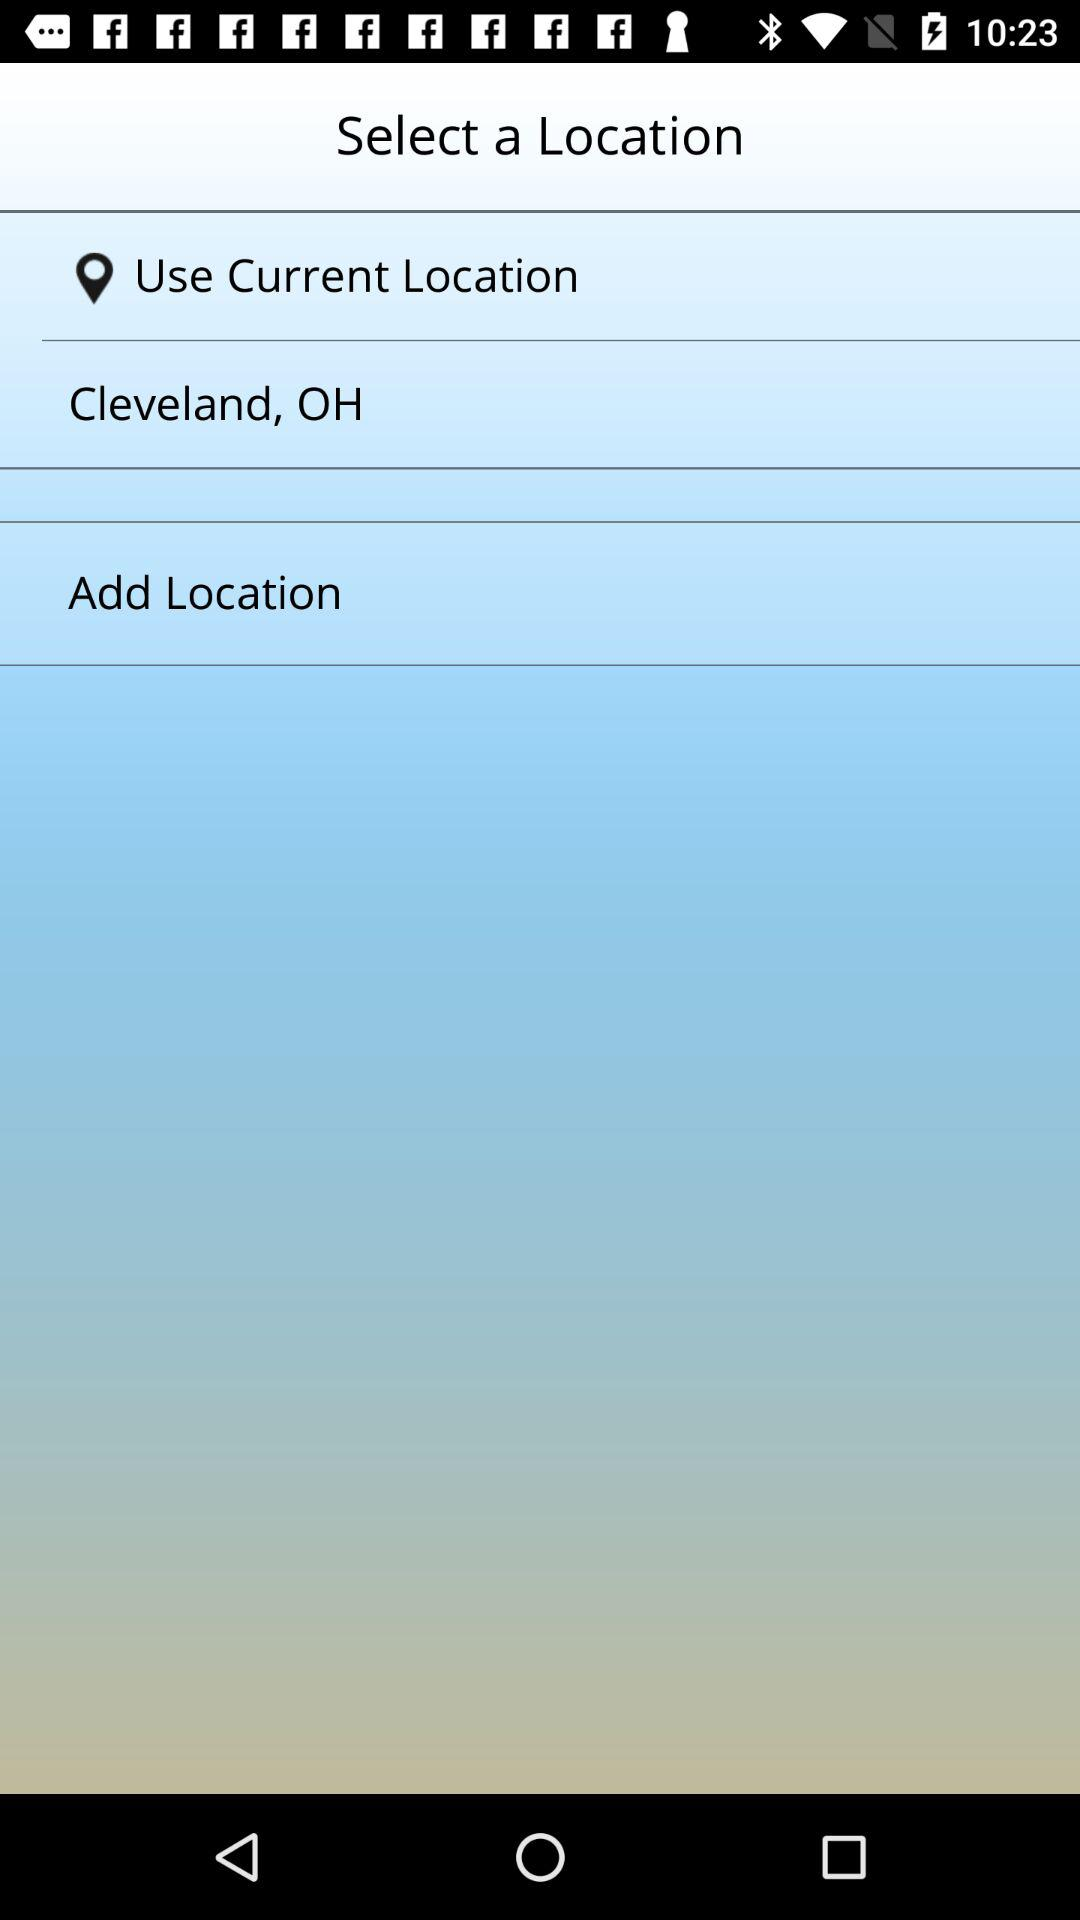What is the current location? The current location is Cleveland, OH. 